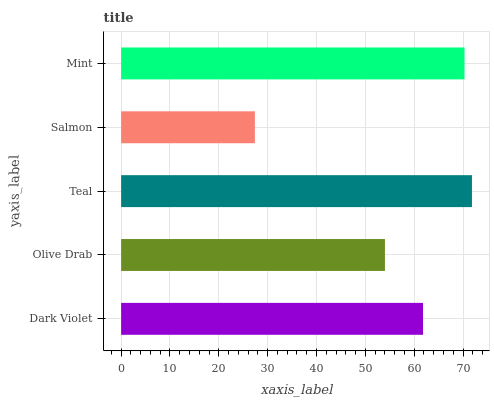Is Salmon the minimum?
Answer yes or no. Yes. Is Teal the maximum?
Answer yes or no. Yes. Is Olive Drab the minimum?
Answer yes or no. No. Is Olive Drab the maximum?
Answer yes or no. No. Is Dark Violet greater than Olive Drab?
Answer yes or no. Yes. Is Olive Drab less than Dark Violet?
Answer yes or no. Yes. Is Olive Drab greater than Dark Violet?
Answer yes or no. No. Is Dark Violet less than Olive Drab?
Answer yes or no. No. Is Dark Violet the high median?
Answer yes or no. Yes. Is Dark Violet the low median?
Answer yes or no. Yes. Is Olive Drab the high median?
Answer yes or no. No. Is Salmon the low median?
Answer yes or no. No. 